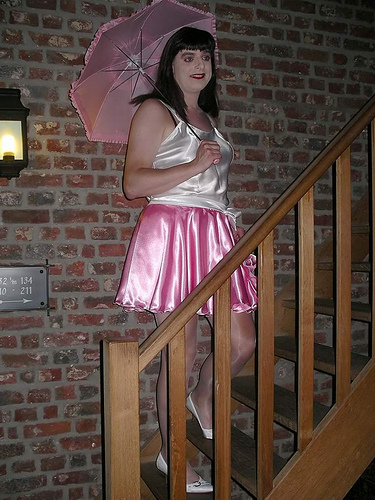<image>
Can you confirm if the sign is behind the light? No. The sign is not behind the light. From this viewpoint, the sign appears to be positioned elsewhere in the scene. 